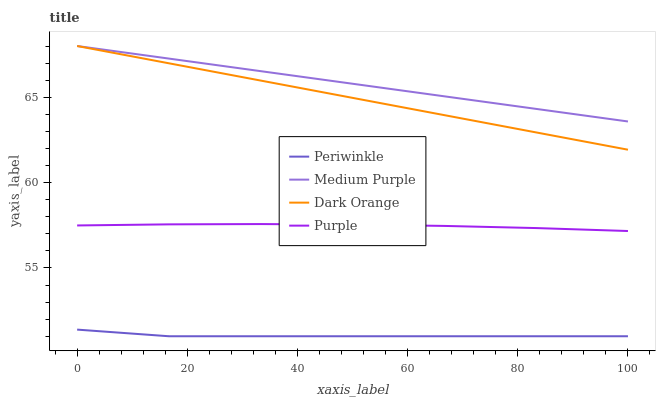Does Periwinkle have the minimum area under the curve?
Answer yes or no. Yes. Does Medium Purple have the maximum area under the curve?
Answer yes or no. Yes. Does Dark Orange have the minimum area under the curve?
Answer yes or no. No. Does Dark Orange have the maximum area under the curve?
Answer yes or no. No. Is Medium Purple the smoothest?
Answer yes or no. Yes. Is Periwinkle the roughest?
Answer yes or no. Yes. Is Dark Orange the smoothest?
Answer yes or no. No. Is Dark Orange the roughest?
Answer yes or no. No. Does Periwinkle have the lowest value?
Answer yes or no. Yes. Does Dark Orange have the lowest value?
Answer yes or no. No. Does Dark Orange have the highest value?
Answer yes or no. Yes. Does Periwinkle have the highest value?
Answer yes or no. No. Is Periwinkle less than Dark Orange?
Answer yes or no. Yes. Is Medium Purple greater than Periwinkle?
Answer yes or no. Yes. Does Medium Purple intersect Dark Orange?
Answer yes or no. Yes. Is Medium Purple less than Dark Orange?
Answer yes or no. No. Is Medium Purple greater than Dark Orange?
Answer yes or no. No. Does Periwinkle intersect Dark Orange?
Answer yes or no. No. 